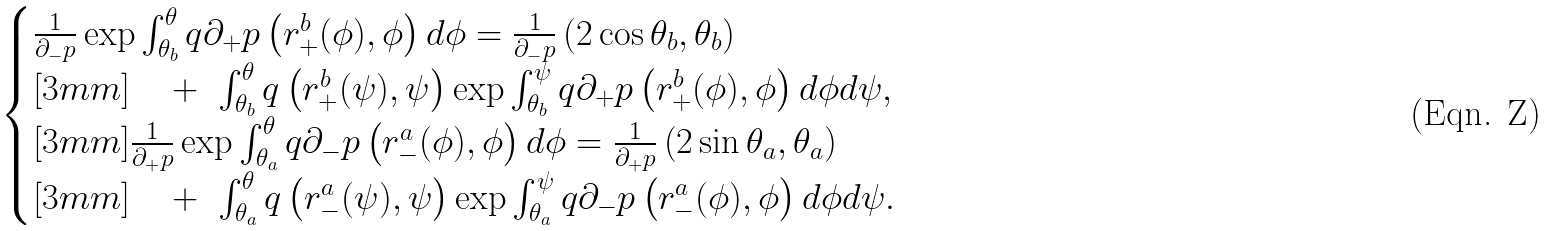<formula> <loc_0><loc_0><loc_500><loc_500>\begin{cases} \frac { 1 } { \partial _ { - } p } \exp \int _ { \theta _ { b } } ^ { \theta } q \partial _ { + } p \left ( r _ { + } ^ { b } ( \phi ) , \phi \right ) d \phi = \frac { 1 } { \partial _ { - } p } \left ( 2 \cos \theta _ { b } , \theta _ { b } \right ) \\ [ 3 m m ] \quad + \ \int _ { \theta _ { b } } ^ { \theta } q \left ( r _ { + } ^ { b } ( \psi ) , \psi \right ) \exp \int _ { \theta _ { b } } ^ { \psi } q \partial _ { + } p \left ( r _ { + } ^ { b } ( \phi ) , \phi \right ) d \phi d \psi , \\ [ 3 m m ] \frac { 1 } { \partial _ { + } p } \exp \int _ { \theta _ { a } } ^ { \theta } q \partial _ { - } p \left ( r _ { - } ^ { a } ( \phi ) , \phi \right ) d \phi = \frac { 1 } { \partial _ { + } p } \left ( 2 \sin \theta _ { a } , \theta _ { a } \right ) \\ [ 3 m m ] \quad + \ \int _ { \theta _ { a } } ^ { \theta } q \left ( r _ { - } ^ { a } ( \psi ) , \psi \right ) \exp \int _ { \theta _ { a } } ^ { \psi } q \partial _ { - } p \left ( r _ { - } ^ { a } ( \phi ) , \phi \right ) d \phi d \psi . \end{cases}</formula> 